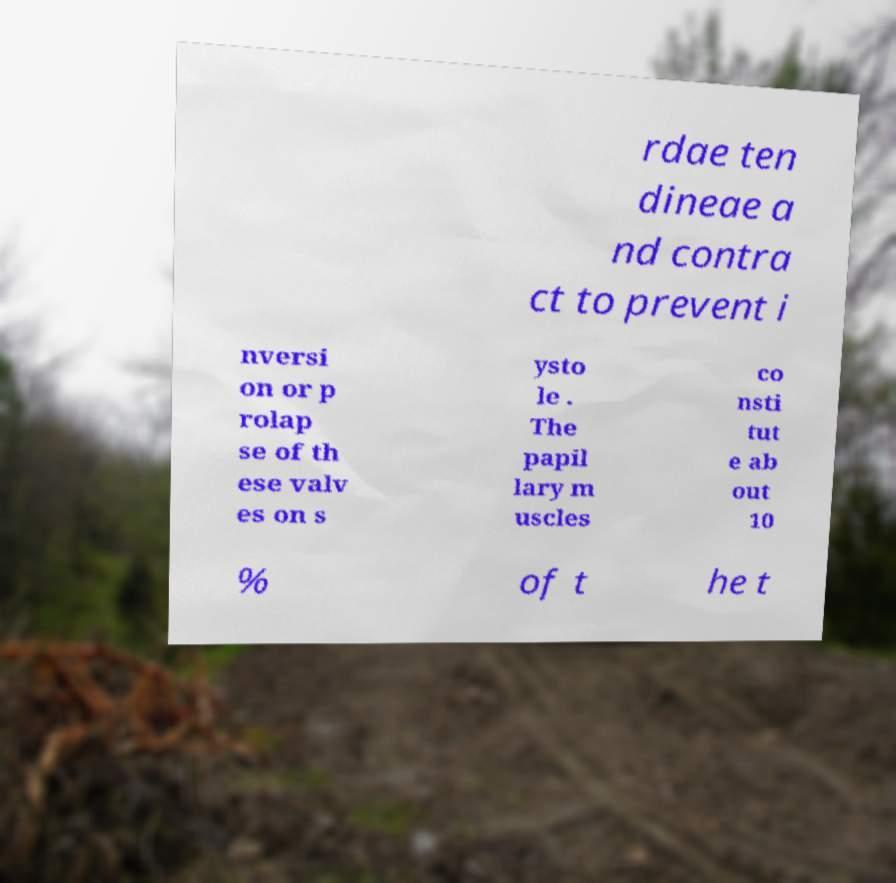For documentation purposes, I need the text within this image transcribed. Could you provide that? rdae ten dineae a nd contra ct to prevent i nversi on or p rolap se of th ese valv es on s ysto le . The papil lary m uscles co nsti tut e ab out 10 % of t he t 